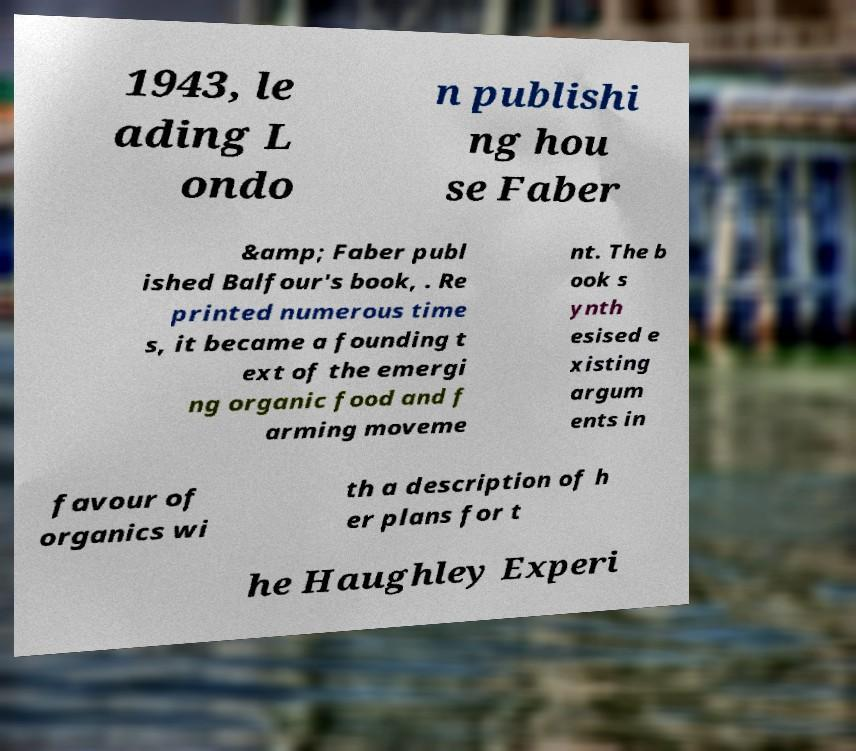Please identify and transcribe the text found in this image. 1943, le ading L ondo n publishi ng hou se Faber &amp; Faber publ ished Balfour's book, . Re printed numerous time s, it became a founding t ext of the emergi ng organic food and f arming moveme nt. The b ook s ynth esised e xisting argum ents in favour of organics wi th a description of h er plans for t he Haughley Experi 